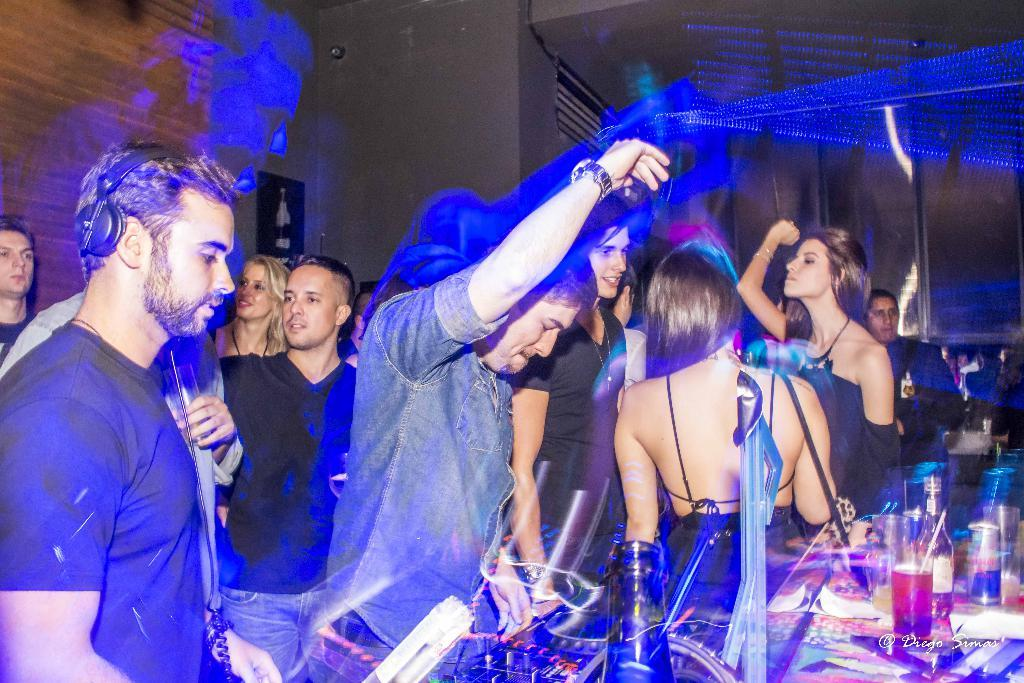Who or what can be seen in the image? There are persons in the image. What objects are visible in the image? There are glasses and other objects in the image. Can you describe the background of the image? There are persons, a wall, and other objects in the background of the image. What type of flame can be seen on the pencil in the image? There is no flame or pencil present in the image. 